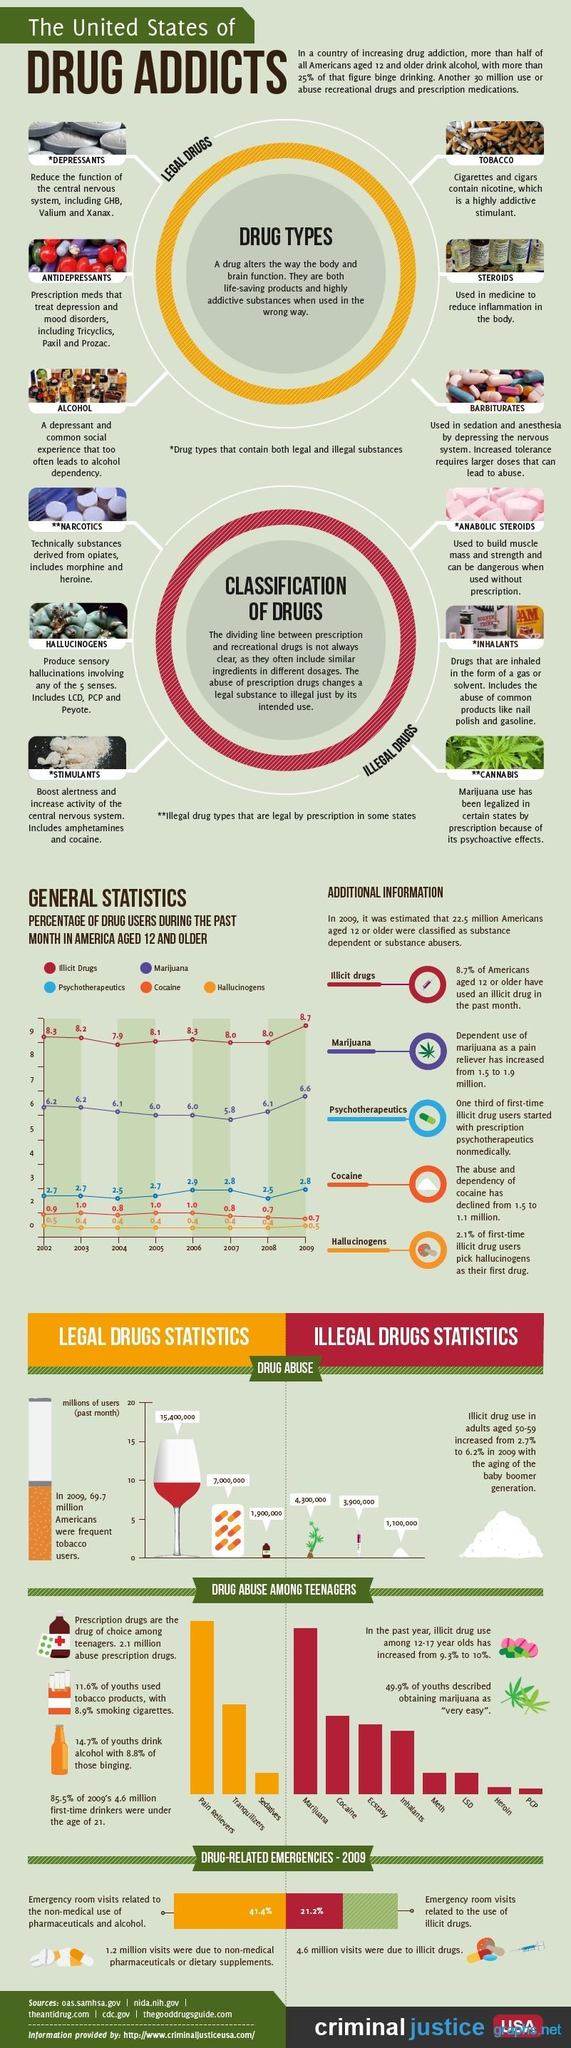Identify some key points in this picture. In 2009, the percentage of drug users using illicit drugs was the highest. According to data from the year 2008, approximately 2.5% of drug users were using psychotherapeutics. In the year 2003, it was estimated that 6.2% of drug users used marijuana. There are six legal drugs listed. According to data from 2007, the percentage of drug users who were using marijuana was the lowest among all years. 